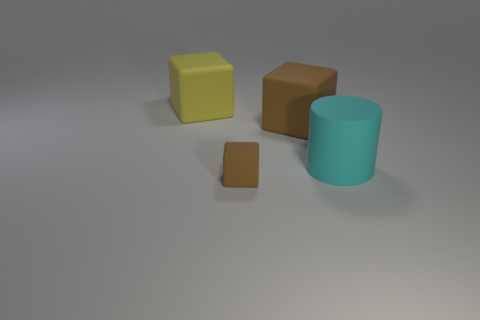What color is the small cube that is made of the same material as the cyan thing?
Make the answer very short. Brown. What number of rubber cylinders are the same size as the yellow rubber thing?
Make the answer very short. 1. What number of other things are the same color as the matte cylinder?
Ensure brevity in your answer.  0. Is there anything else that is the same size as the cyan matte thing?
Your answer should be very brief. Yes. Is the shape of the object behind the large brown object the same as the thing that is in front of the large cyan matte cylinder?
Provide a succinct answer. Yes. There is a brown object that is the same size as the cyan cylinder; what shape is it?
Make the answer very short. Cube. Are there an equal number of rubber cylinders that are behind the yellow matte object and brown matte cubes on the right side of the small matte object?
Your answer should be very brief. No. Are there any other things that have the same shape as the big brown thing?
Ensure brevity in your answer.  Yes. Do the brown block behind the tiny brown rubber object and the big cyan cylinder have the same material?
Your response must be concise. Yes. What is the material of the yellow thing that is the same size as the cyan cylinder?
Your answer should be very brief. Rubber. 